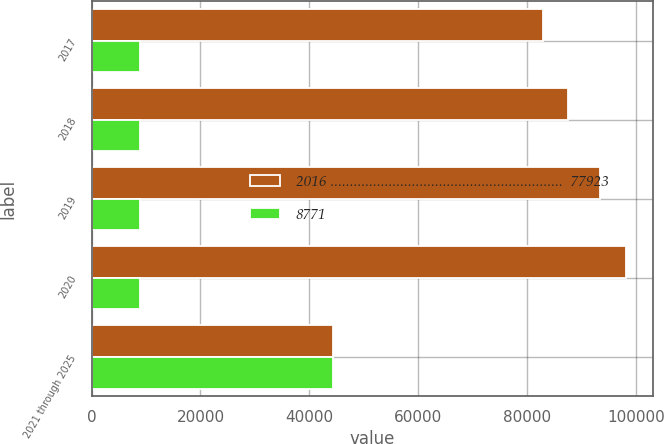Convert chart. <chart><loc_0><loc_0><loc_500><loc_500><stacked_bar_chart><ecel><fcel>2017<fcel>2018<fcel>2019<fcel>2020<fcel>2021 through 2025<nl><fcel>2016 ............................................................  77923<fcel>82899<fcel>87480<fcel>93309<fcel>98138<fcel>44338<nl><fcel>8771<fcel>8834<fcel>8952<fcel>8979<fcel>8973<fcel>44338<nl></chart> 